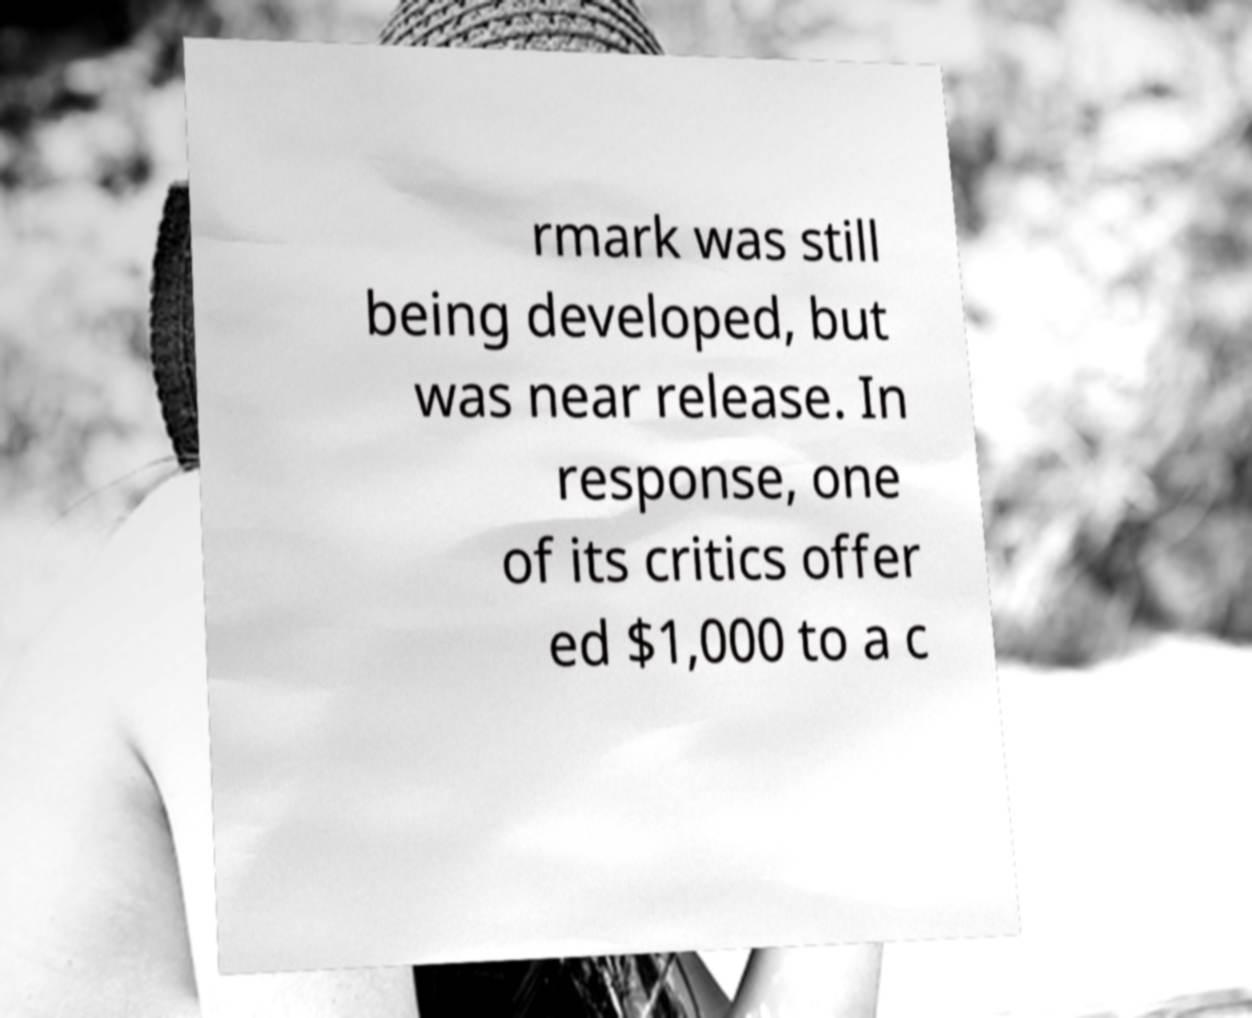Could you extract and type out the text from this image? rmark was still being developed, but was near release. In response, one of its critics offer ed $1,000 to a c 